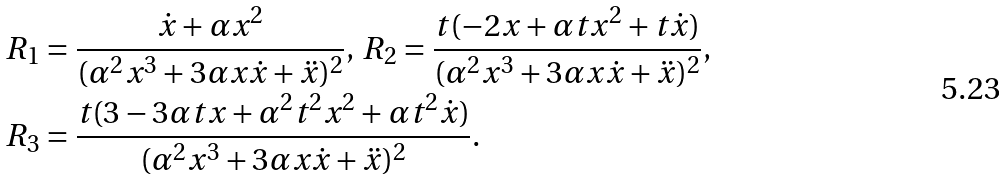Convert formula to latex. <formula><loc_0><loc_0><loc_500><loc_500>& R _ { 1 } = \frac { \dot { x } + \alpha x ^ { 2 } } { ( \alpha ^ { 2 } x ^ { 3 } + 3 \alpha x \dot { x } + \ddot { x } ) ^ { 2 } } , \, R _ { 2 } = \frac { t ( - 2 x + \alpha t x ^ { 2 } + t \dot { x } ) } { ( \alpha ^ { 2 } x ^ { 3 } + 3 \alpha x \dot { x } + \ddot { x } ) ^ { 2 } } , \\ & R _ { 3 } = \frac { t ( 3 - 3 \alpha t x + \alpha ^ { 2 } t ^ { 2 } x ^ { 2 } + \alpha t ^ { 2 } \dot { x } ) } { ( \alpha ^ { 2 } x ^ { 3 } + 3 \alpha x \dot { x } + \ddot { x } ) ^ { 2 } } .</formula> 